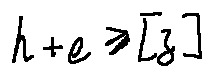Convert formula to latex. <formula><loc_0><loc_0><loc_500><loc_500>h + e \geq [ z ]</formula> 